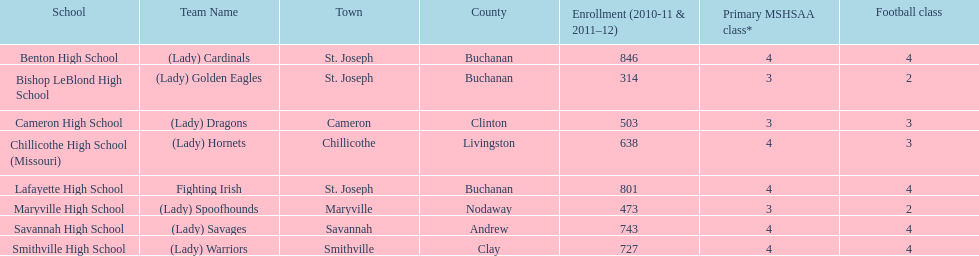What team uses green and grey as colors? Fighting Irish. What is this team called? Lafayette High School. 